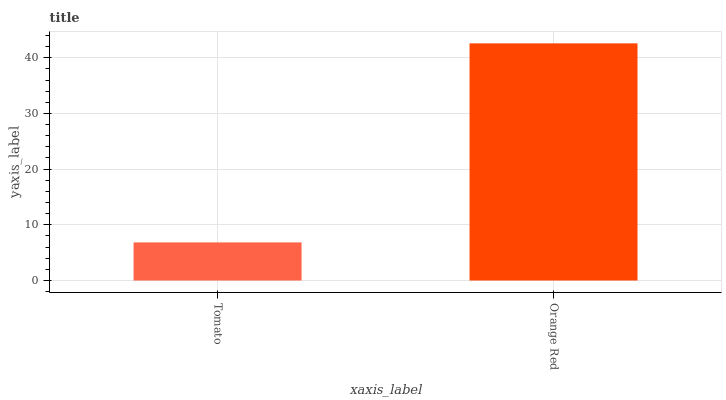Is Tomato the minimum?
Answer yes or no. Yes. Is Orange Red the maximum?
Answer yes or no. Yes. Is Orange Red the minimum?
Answer yes or no. No. Is Orange Red greater than Tomato?
Answer yes or no. Yes. Is Tomato less than Orange Red?
Answer yes or no. Yes. Is Tomato greater than Orange Red?
Answer yes or no. No. Is Orange Red less than Tomato?
Answer yes or no. No. Is Orange Red the high median?
Answer yes or no. Yes. Is Tomato the low median?
Answer yes or no. Yes. Is Tomato the high median?
Answer yes or no. No. Is Orange Red the low median?
Answer yes or no. No. 